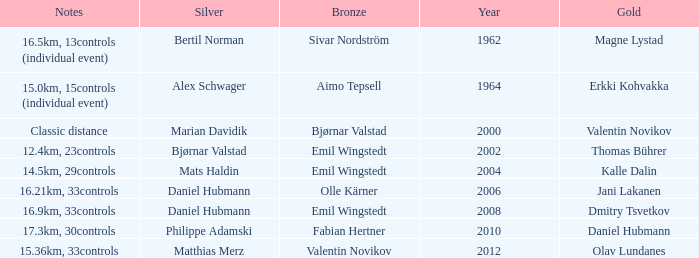WHAT IS THE YEAR WITH A BRONZE OF AIMO TEPSELL? 1964.0. 